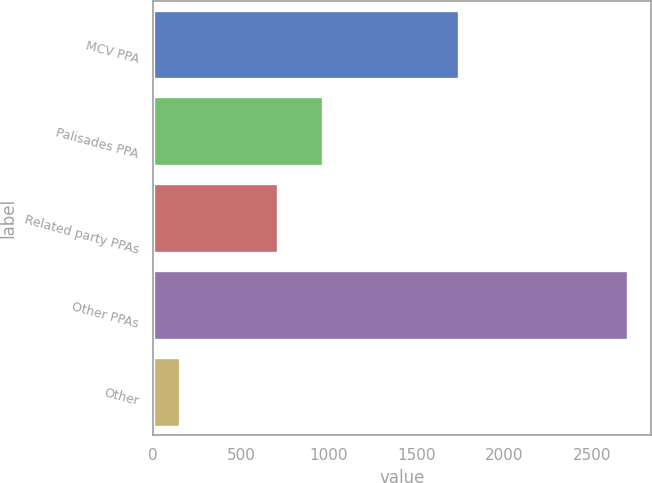<chart> <loc_0><loc_0><loc_500><loc_500><bar_chart><fcel>MCV PPA<fcel>Palisades PPA<fcel>Related party PPAs<fcel>Other PPAs<fcel>Other<nl><fcel>1742<fcel>965.8<fcel>711<fcel>2701<fcel>153<nl></chart> 